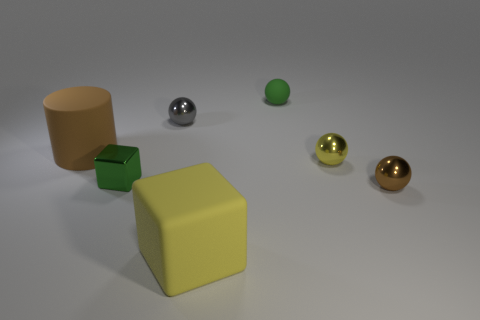There is a tiny thing that is the same color as the small cube; what is it made of?
Your answer should be compact. Rubber. What number of objects are either green objects to the right of the large yellow rubber thing or tiny green objects left of the tiny gray thing?
Provide a short and direct response. 2. Are there fewer tiny gray metal things than small yellow rubber spheres?
Your response must be concise. No. What shape is the green metal object that is the same size as the yellow metal sphere?
Provide a short and direct response. Cube. What number of other things are there of the same color as the rubber cube?
Give a very brief answer. 1. How many gray metal spheres are there?
Ensure brevity in your answer.  1. How many objects are both in front of the tiny gray metallic sphere and on the left side of the tiny brown thing?
Your answer should be compact. 4. What is the material of the small gray thing?
Your answer should be very brief. Metal. Is there a gray block?
Your answer should be very brief. No. There is a large matte thing that is to the right of the cylinder; what color is it?
Your answer should be compact. Yellow. 